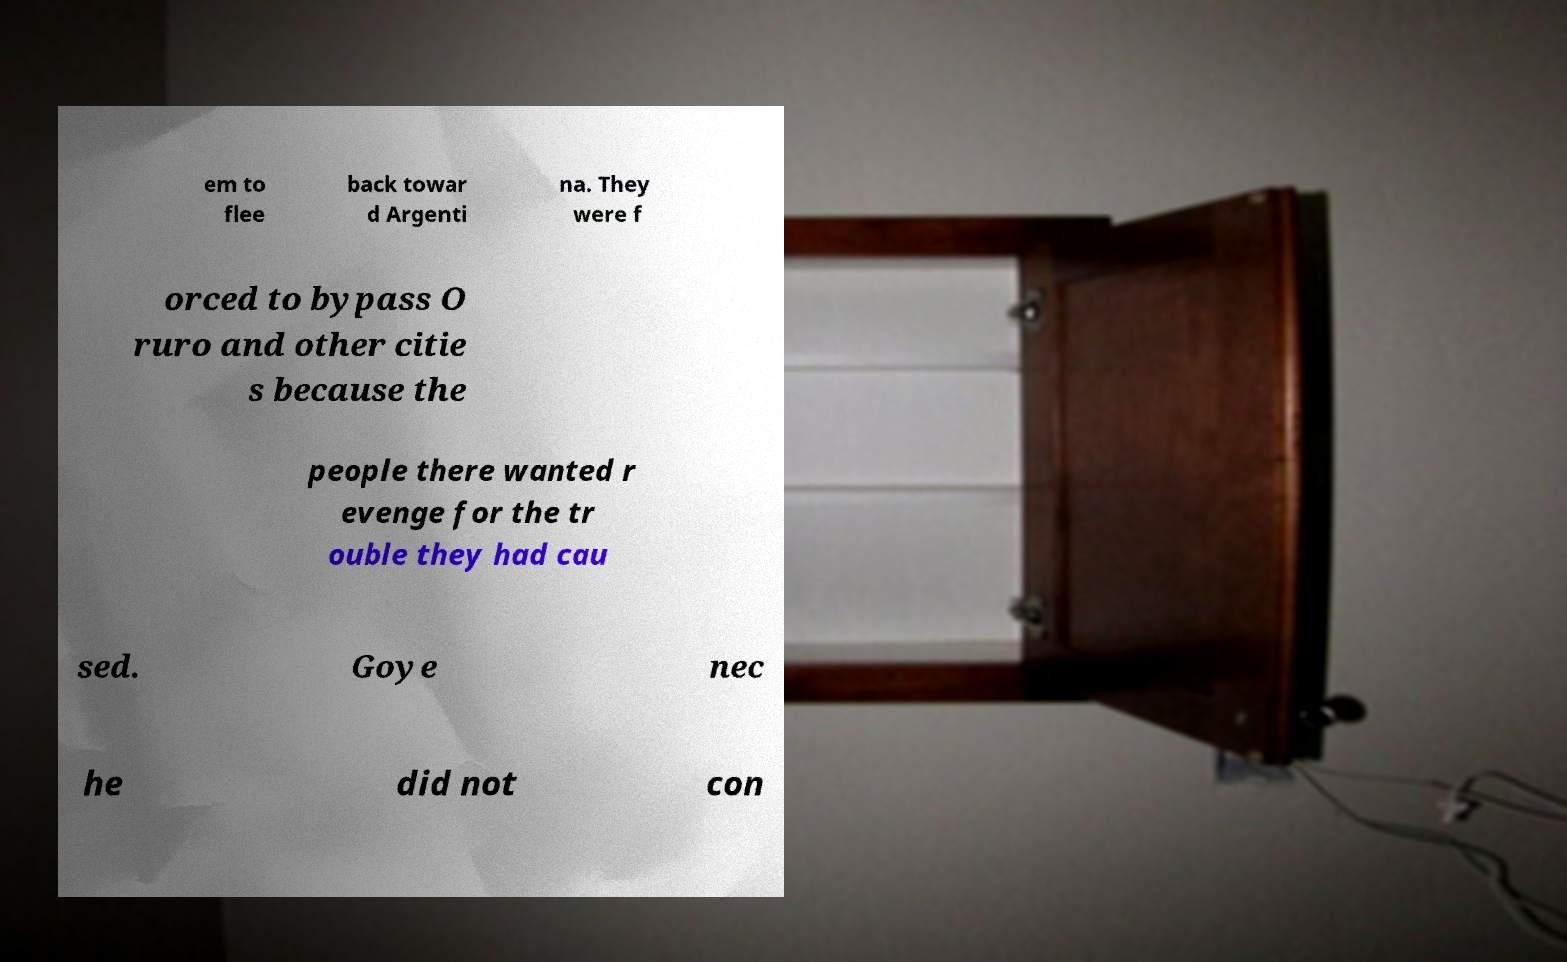Can you read and provide the text displayed in the image?This photo seems to have some interesting text. Can you extract and type it out for me? em to flee back towar d Argenti na. They were f orced to bypass O ruro and other citie s because the people there wanted r evenge for the tr ouble they had cau sed. Goye nec he did not con 